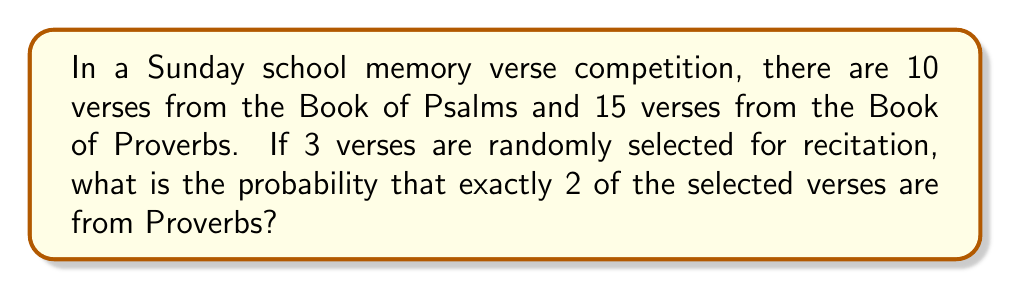Can you solve this math problem? Let's approach this step-by-step using the concepts of combinatorics:

1) First, we need to calculate the total number of ways to select 3 verses from the 25 total verses:
   $$\binom{25}{3} = \frac{25!}{3!(25-3)!} = \frac{25!}{3!22!} = 2300$$

2) Now, we need to calculate the number of ways to select 2 verses from Proverbs and 1 from Psalms:
   - Select 2 from Proverbs: $\binom{15}{2} = \frac{15!}{2!13!} = 105$
   - Select 1 from Psalms: $\binom{10}{1} = 10$

3) Multiply these together to get the total number of favorable outcomes:
   $$105 \times 10 = 1050$$

4) The probability is then the number of favorable outcomes divided by the total number of possible outcomes:
   $$P(\text{2 from Proverbs}) = \frac{1050}{2300} = \frac{21}{46} \approx 0.4565$$
Answer: $\frac{21}{46}$ 